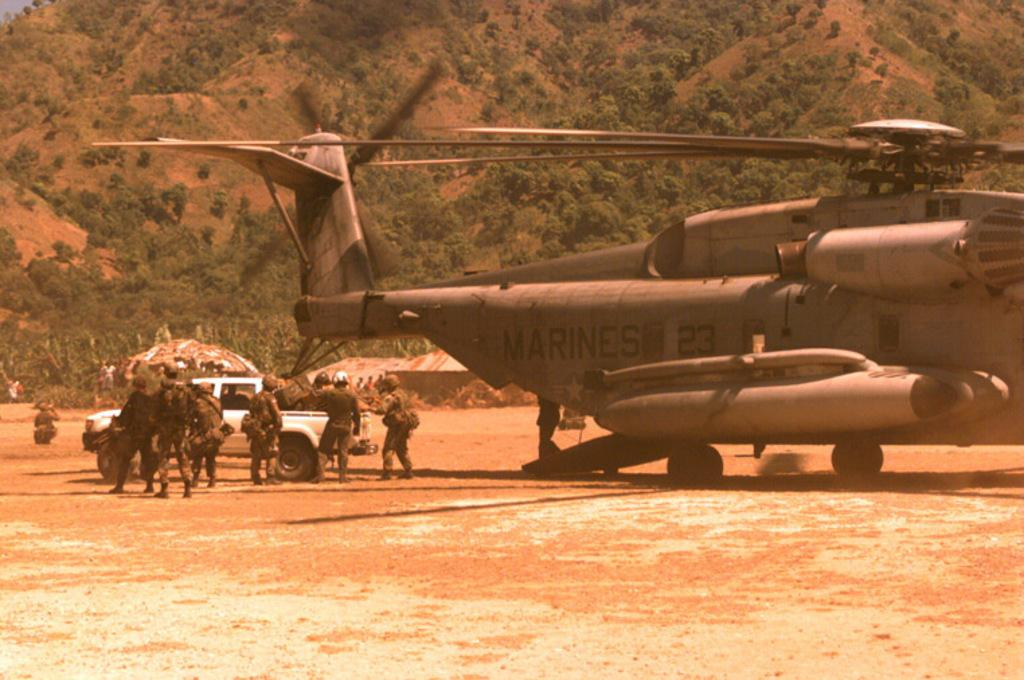What is the main subject of the image? The main subject of the image is an aeroplane. What else can be seen in the image besides the aeroplane? There are people around a car and trees, a mountain, and a shed visible in the background of the image. How many babies are kicking a quince in the image? There are no babies or quince present in the image. 